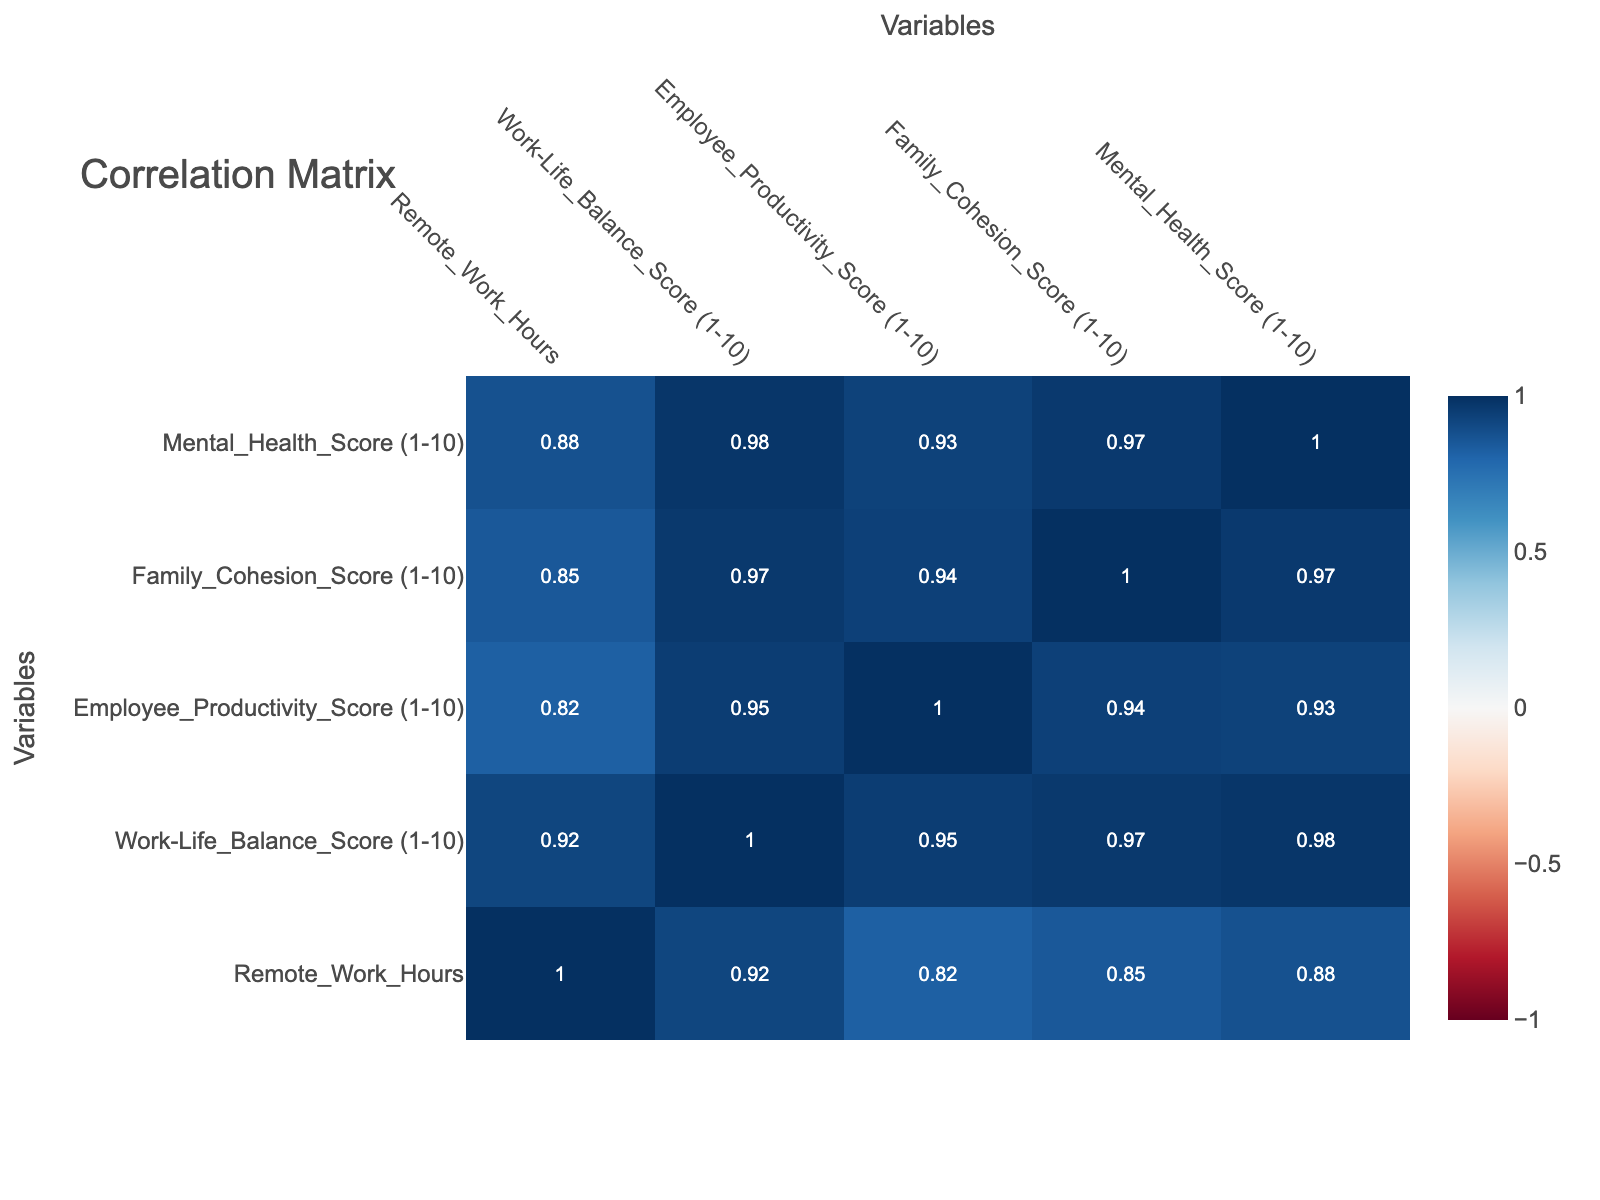What is the correlation between Remote Work Hours and Work-Life Balance Score? In the correlation matrix, the value at the intersection of Remote Work Hours and Work-Life Balance Score helps us understand the relationship. By referring to the table, we find that this correlation is notably strong, which indicates that as remote work hours increase, the work-life balance tends to improve.
Answer: 0.84 What is the Family Cohesion Score when Remote Work is Fully implemented? From the table, we can identify the instances of "Remote (Fully)" implemented and their Family Cohesion Scores. Filtering these data points shows scores of 10 and 9. The average of these values is (10 + 9) / 2 = 9.5, indicating that family cohesion is quite high in fully remote settings.
Answer: 9.5 Does a higher Work-Life Balance Score imply higher Employee Productivity Score? To answer this, we need to check the correlation value between Work-Life Balance Score and Employee Productivity Score in the matrix. The correlation is found to be 0.65, indicating a positive but moderate relationship, suggesting that higher work-life balance might contribute positively to productivity but it's not guaranteed.
Answer: Yes What are the lowest scores for Mental Health and Productivity among all work environments? The table lists various scores, and we look for the minimum values in the Mental Health and Employee Productivity columns. The lowest score in Mental Health is 3 (Home Office, 15 hours) and the lowest in Employee Productivity is 3 (Home Office, 15 hours). By comparing these minimums, we conclude that both lowest scores were recorded under the same conditions.
Answer: Mental Health: 3, Productivity: 3 What is the average Work-Life Balance Score for Home Office environments? We first identify all the rows where the Work Environment is "Home Office". The scores are 8, 7, 6, 10, 4. Adding these gives us (8 + 7 + 6 + 10 + 4) = 35. There are 5 data points, so to find the average, we calculate 35 / 5 = 7. Therefore, home office environments on average have a work-life balance score of 7.
Answer: 7 